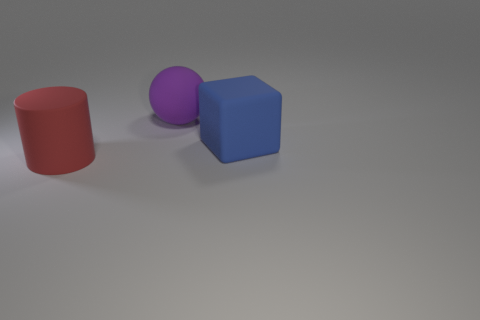What number of shiny objects are either cubes or blue cylinders? There is one blue cube in the image, but no blue cylinders. Therefore, there is a total of one object that meets the criteria of being either a cube or a blue cylinder. 